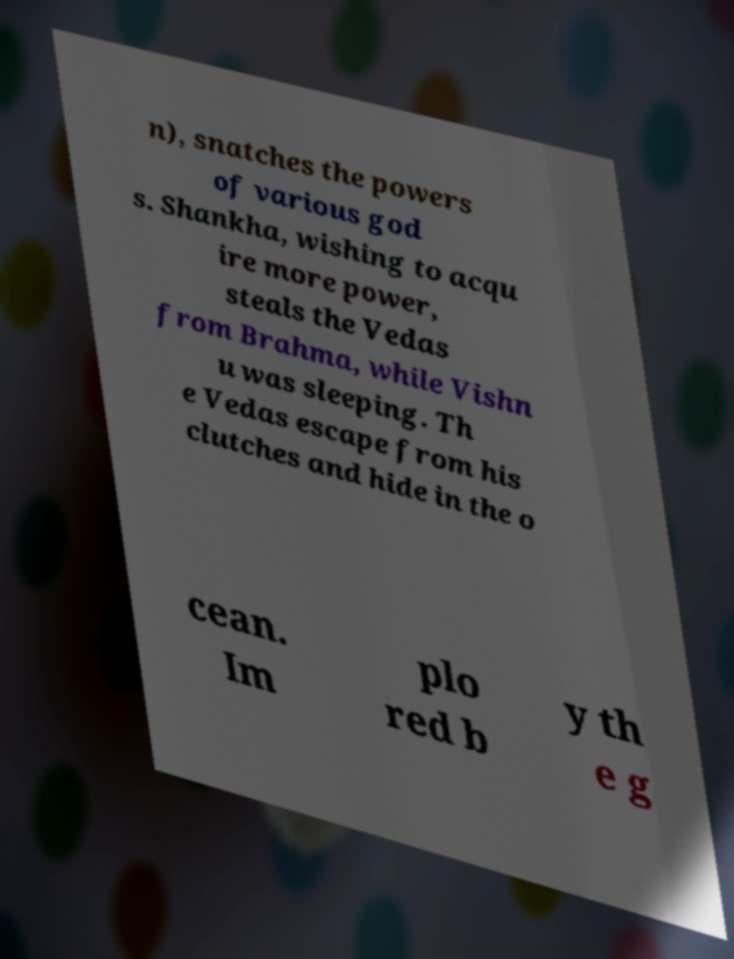Please read and relay the text visible in this image. What does it say? n), snatches the powers of various god s. Shankha, wishing to acqu ire more power, steals the Vedas from Brahma, while Vishn u was sleeping. Th e Vedas escape from his clutches and hide in the o cean. Im plo red b y th e g 